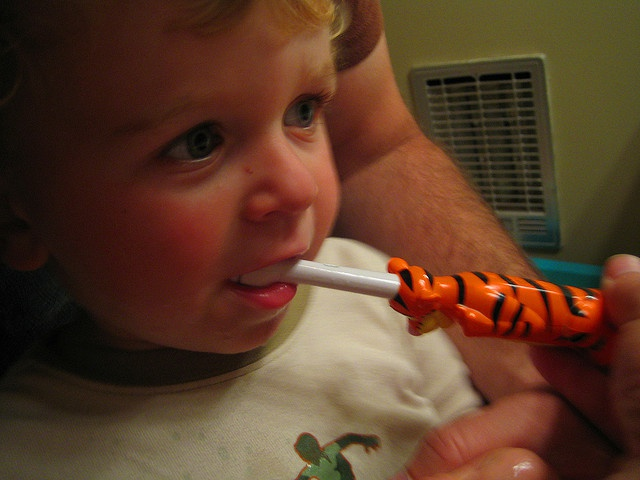Describe the objects in this image and their specific colors. I can see people in black, maroon, tan, and gray tones, people in black, brown, and maroon tones, and toothbrush in black, brown, red, and maroon tones in this image. 